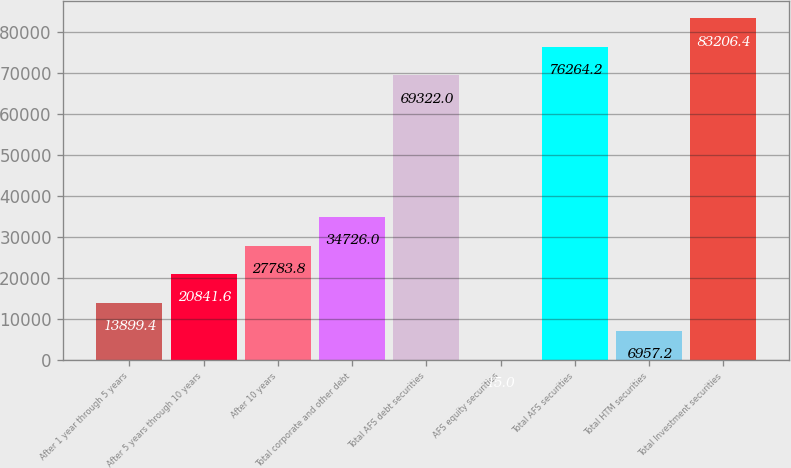<chart> <loc_0><loc_0><loc_500><loc_500><bar_chart><fcel>After 1 year through 5 years<fcel>After 5 years through 10 years<fcel>After 10 years<fcel>Total corporate and other debt<fcel>Total AFS debt securities<fcel>AFS equity securities<fcel>Total AFS securities<fcel>Total HTM securities<fcel>Total Investment securities<nl><fcel>13899.4<fcel>20841.6<fcel>27783.8<fcel>34726<fcel>69322<fcel>15<fcel>76264.2<fcel>6957.2<fcel>83206.4<nl></chart> 